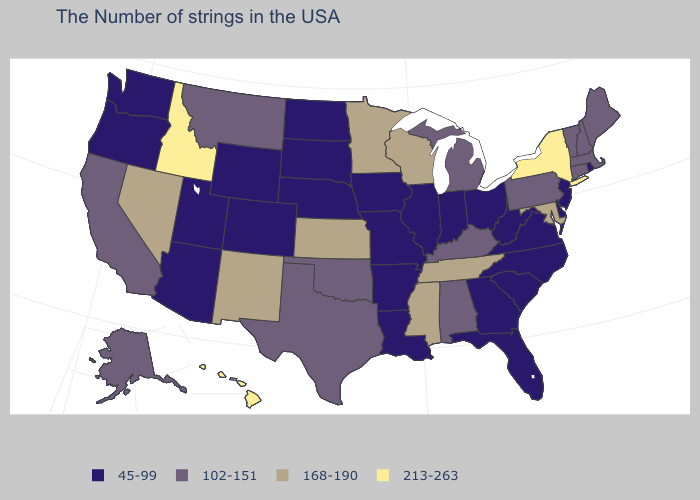What is the highest value in the MidWest ?
Write a very short answer. 168-190. Among the states that border Missouri , which have the highest value?
Keep it brief. Tennessee, Kansas. Does the first symbol in the legend represent the smallest category?
Concise answer only. Yes. What is the value of Washington?
Concise answer only. 45-99. What is the lowest value in states that border North Carolina?
Give a very brief answer. 45-99. What is the value of Maine?
Short answer required. 102-151. What is the lowest value in the USA?
Give a very brief answer. 45-99. Among the states that border Indiana , does Ohio have the highest value?
Be succinct. No. Does Idaho have the highest value in the USA?
Be succinct. Yes. What is the highest value in states that border Minnesota?
Quick response, please. 168-190. What is the highest value in the USA?
Short answer required. 213-263. Name the states that have a value in the range 213-263?
Short answer required. New York, Idaho, Hawaii. What is the highest value in the USA?
Keep it brief. 213-263. Name the states that have a value in the range 102-151?
Write a very short answer. Maine, Massachusetts, New Hampshire, Vermont, Connecticut, Pennsylvania, Michigan, Kentucky, Alabama, Oklahoma, Texas, Montana, California, Alaska. What is the highest value in the MidWest ?
Quick response, please. 168-190. 